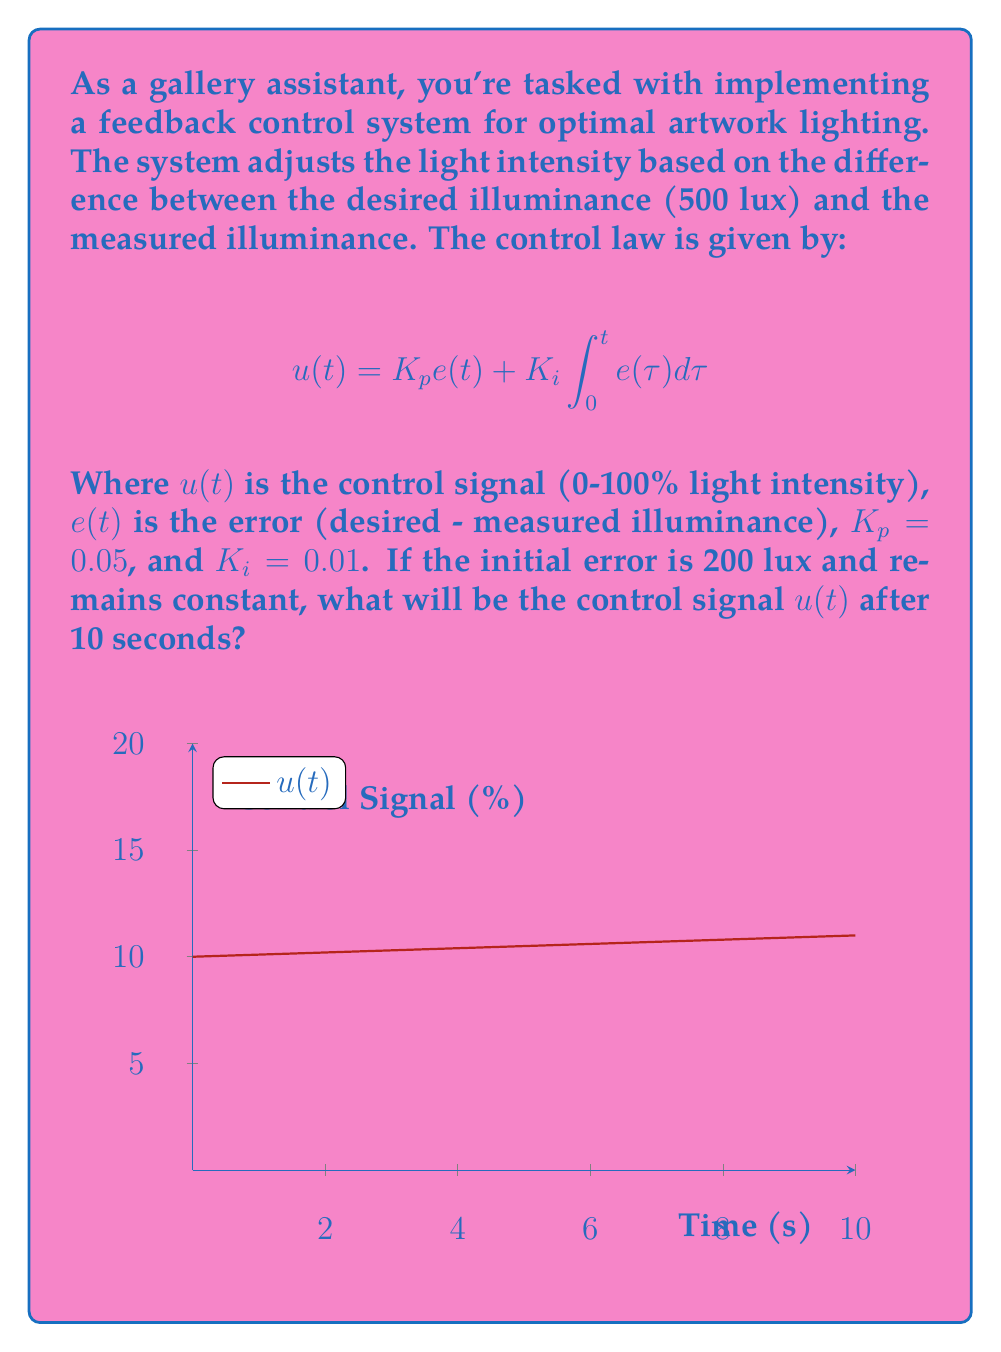Can you solve this math problem? Let's approach this step-by-step:

1) The error $e(t)$ is constant at 200 lux, so $e(t) = 200$ for all $t$.

2) We need to calculate two terms: the proportional term and the integral term.

3) Proportional term:
   $$K_p e(t) = 0.05 \times 200 = 10$$

4) Integral term:
   $$K_i \int_0^t e(\tau) d\tau = 0.01 \int_0^{10} 200 d\tau$$
   $$= 0.01 \times 200 \times 10 = 20$$

5) The control signal $u(t)$ is the sum of these terms:
   $$u(10) = 10 + 20 = 30$$

Therefore, after 10 seconds, the control signal will be 30% of the maximum light intensity.
Answer: 30% 